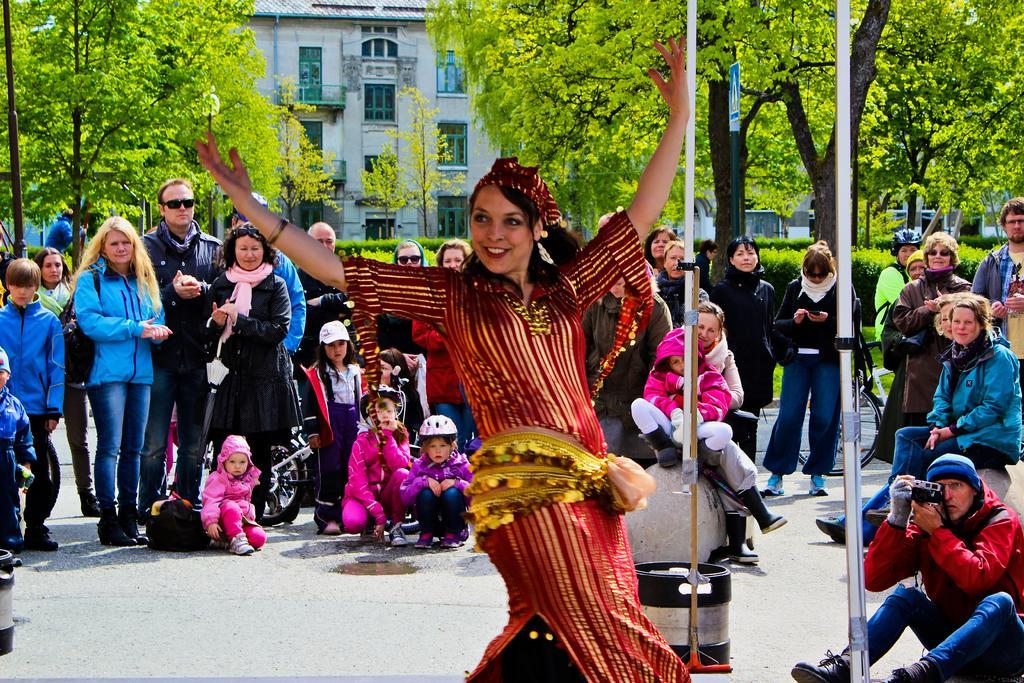Could you give a brief overview of what you see in this image? In this picture we can see a woman is dancing in the front, in the background there are some trees and a building, we can see some people are standing and some people are sitting in the middle, we can also see plants in the background, a person at the right bottom is holding a camera. 